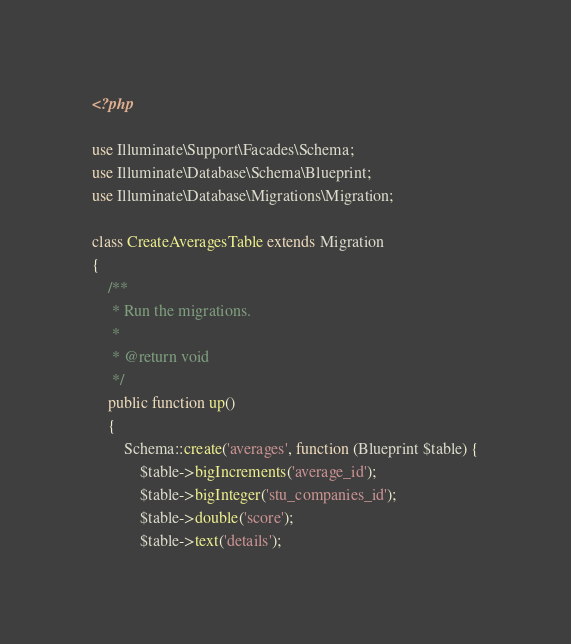<code> <loc_0><loc_0><loc_500><loc_500><_PHP_><?php

use Illuminate\Support\Facades\Schema;
use Illuminate\Database\Schema\Blueprint;
use Illuminate\Database\Migrations\Migration;

class CreateAveragesTable extends Migration
{
    /**
     * Run the migrations.
     *
     * @return void
     */
    public function up()
    {
        Schema::create('averages', function (Blueprint $table) {
            $table->bigIncrements('average_id');
            $table->bigInteger('stu_companies_id');
            $table->double('score');
            $table->text('details');</code> 